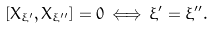Convert formula to latex. <formula><loc_0><loc_0><loc_500><loc_500>[ X _ { \xi ^ { \prime } } , X _ { \xi ^ { \prime \prime } } ] = 0 \, \Longleftrightarrow \, \xi ^ { \prime } = \xi ^ { \prime \prime } .</formula> 